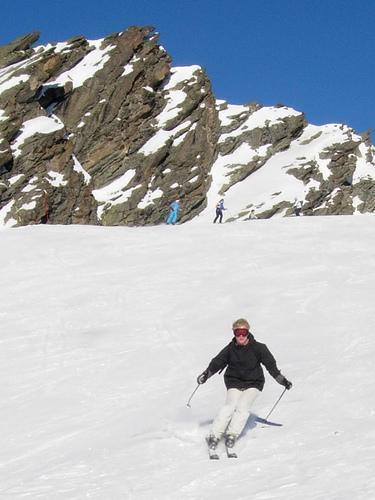What is the geological rock formation called?
Pick the correct solution from the four options below to address the question.
Options: Bump out, rock out, stick out, outcrop. Outcrop. 